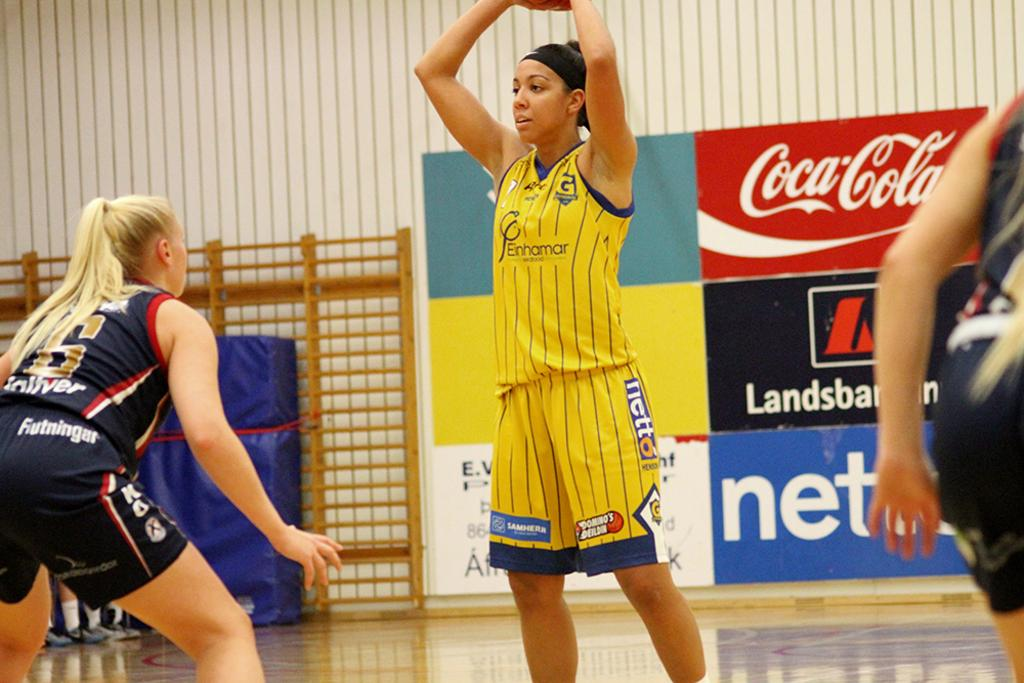<image>
Provide a brief description of the given image. two women's basketball teams playing on a court sponsored by coca cola 